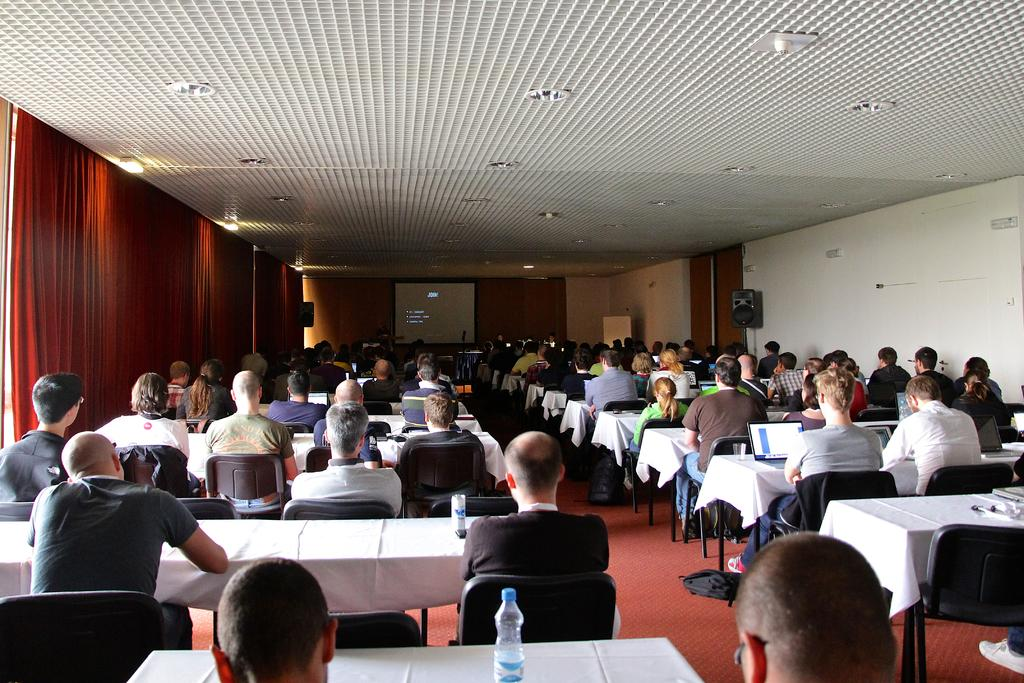What are the people in the image doing? The people in the image are sitting on chairs. Where are the chairs located in relation to the table? The chairs are in front of a table. What is on the wall in the image? There is a screen on the wall. What type of setting does the image depict? The setting resembles a conference room. How often do the people in the image wash their hands? There is no information about the people washing their hands in the image, so it cannot be determined. 